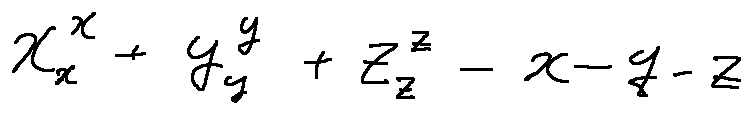<formula> <loc_0><loc_0><loc_500><loc_500>x _ { x } ^ { x } + y _ { y } ^ { y } + z _ { z } ^ { z } - x - y - z</formula> 